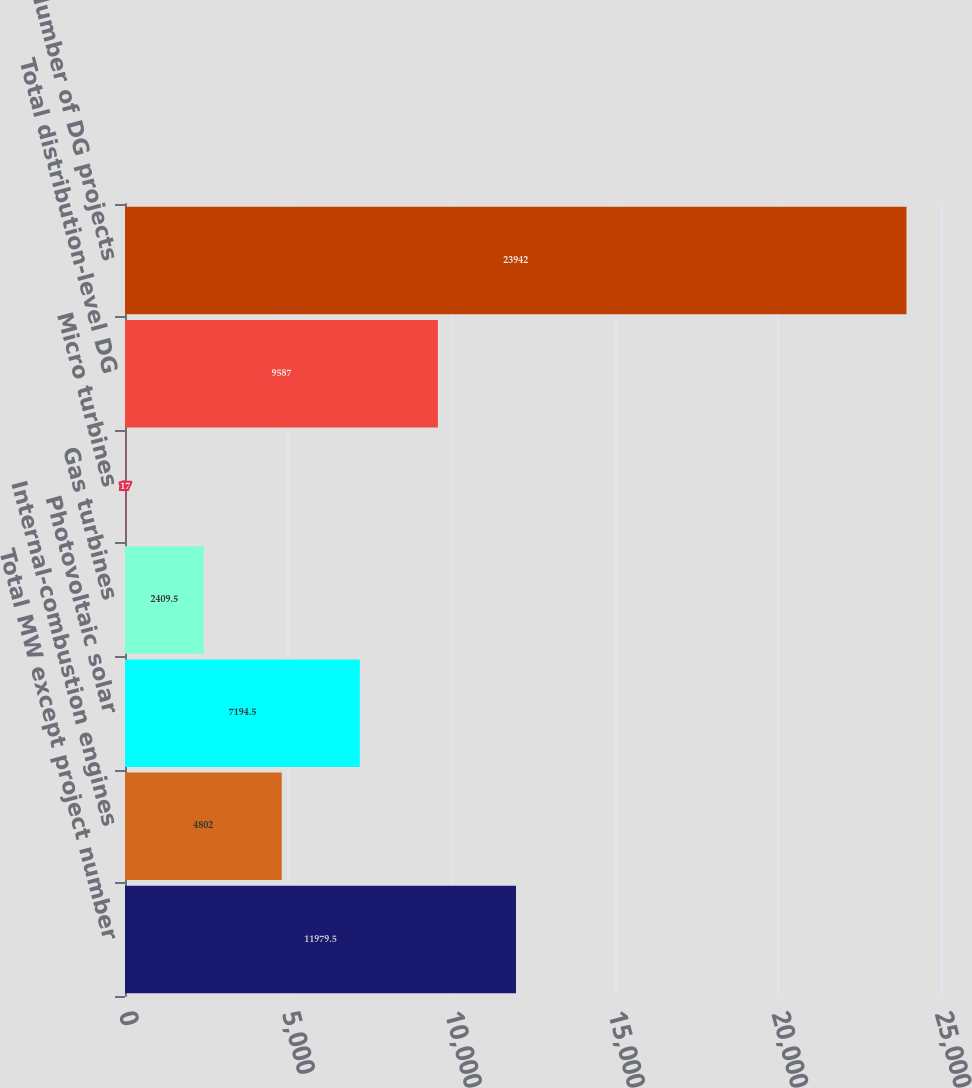Convert chart to OTSL. <chart><loc_0><loc_0><loc_500><loc_500><bar_chart><fcel>Total MW except project number<fcel>Internal-combustion engines<fcel>Photovoltaic solar<fcel>Gas turbines<fcel>Micro turbines<fcel>Total distribution-level DG<fcel>Number of DG projects<nl><fcel>11979.5<fcel>4802<fcel>7194.5<fcel>2409.5<fcel>17<fcel>9587<fcel>23942<nl></chart> 